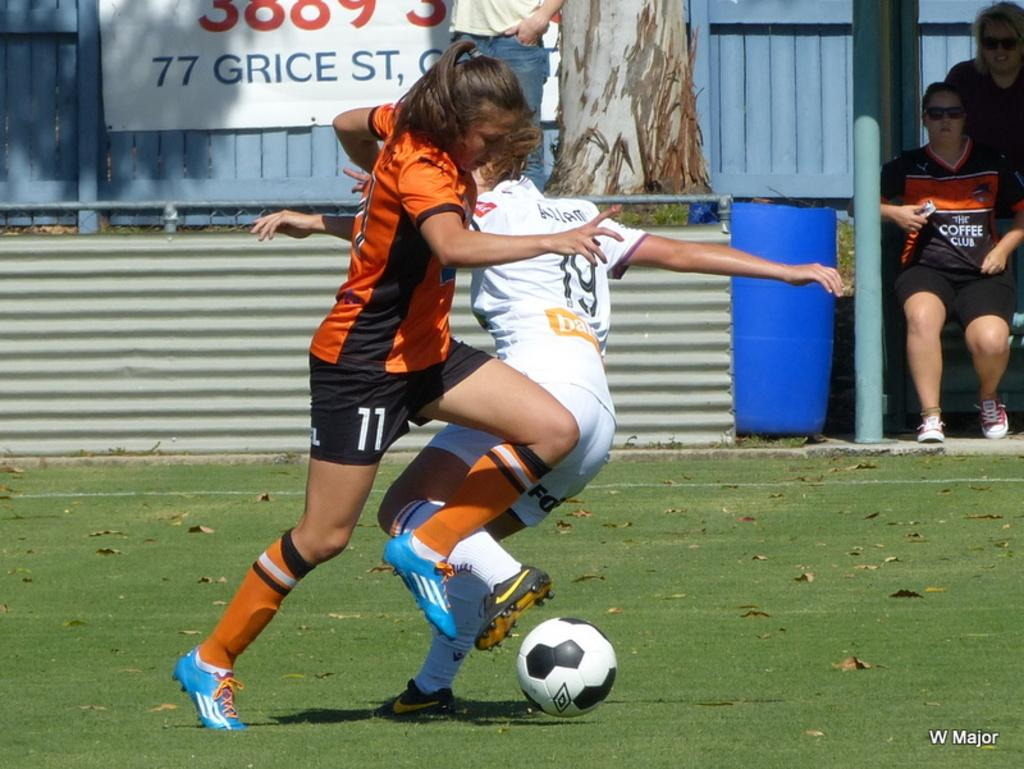What are the two persons in the image doing? The two persons in the image are playing football. What can be seen in the background of the image? There is a branch, a hoarding, a roof, and a blue color drum visible in the background. Are there any other people present in the image? Yes, there are two persons sitting in the background. What type of yak can be seen grazing on the sidewalk in the image? There is no yak or sidewalk present in the image. 